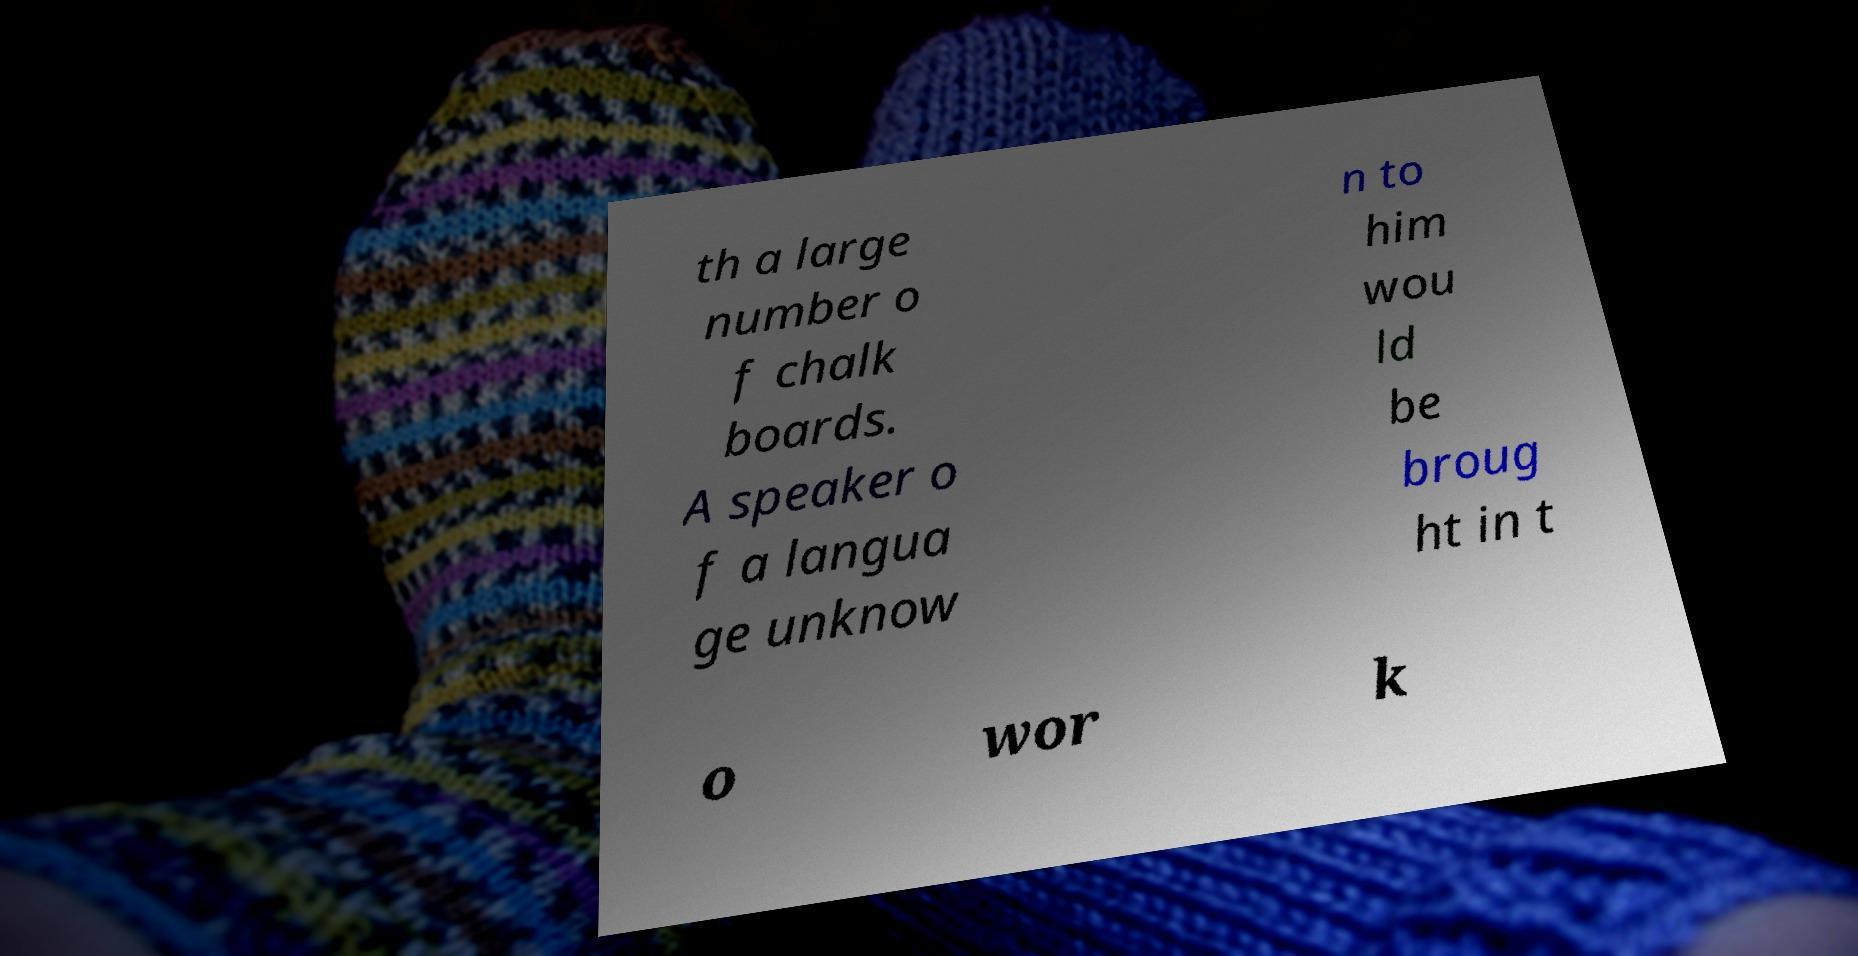I need the written content from this picture converted into text. Can you do that? th a large number o f chalk boards. A speaker o f a langua ge unknow n to him wou ld be broug ht in t o wor k 